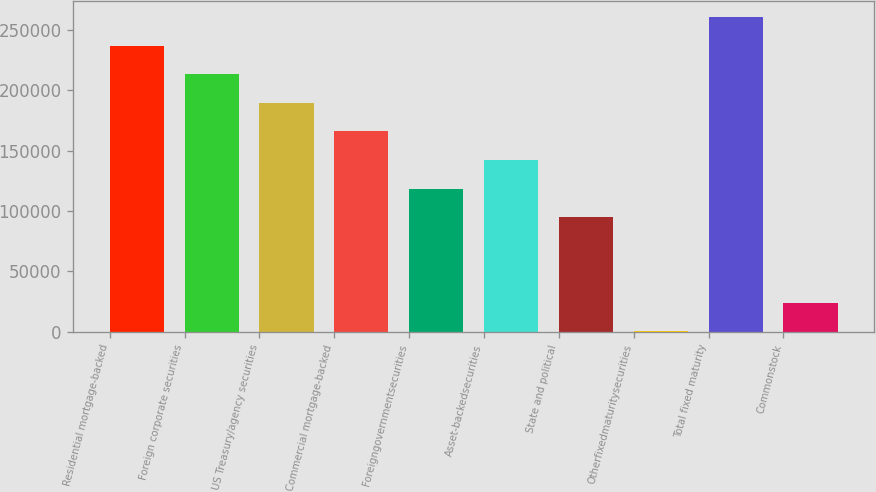Convert chart to OTSL. <chart><loc_0><loc_0><loc_500><loc_500><bar_chart><fcel>Residential mortgage-backed<fcel>Foreign corporate securities<fcel>US Treasury/agency securities<fcel>Commercial mortgage-backed<fcel>Foreigngovernmentsecurities<fcel>Asset-backedsecurities<fcel>State and political<fcel>Otherfixedmaturitysecurities<fcel>Total fixed maturity<fcel>Commonstock<nl><fcel>236768<fcel>213130<fcel>189491<fcel>165853<fcel>118576<fcel>142215<fcel>94938.2<fcel>385<fcel>260406<fcel>24023.3<nl></chart> 